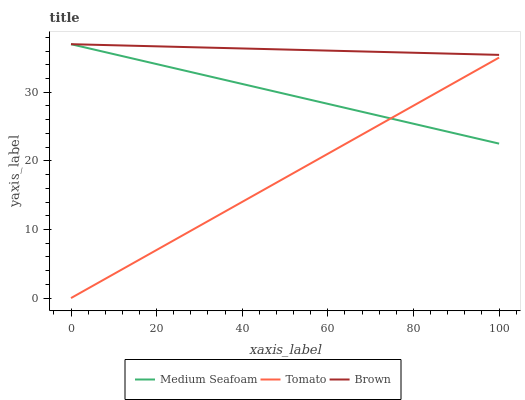Does Tomato have the minimum area under the curve?
Answer yes or no. Yes. Does Brown have the maximum area under the curve?
Answer yes or no. Yes. Does Medium Seafoam have the minimum area under the curve?
Answer yes or no. No. Does Medium Seafoam have the maximum area under the curve?
Answer yes or no. No. Is Tomato the smoothest?
Answer yes or no. Yes. Is Brown the roughest?
Answer yes or no. Yes. Is Medium Seafoam the smoothest?
Answer yes or no. No. Is Medium Seafoam the roughest?
Answer yes or no. No. Does Tomato have the lowest value?
Answer yes or no. Yes. Does Medium Seafoam have the lowest value?
Answer yes or no. No. Does Medium Seafoam have the highest value?
Answer yes or no. Yes. Is Tomato less than Brown?
Answer yes or no. Yes. Is Brown greater than Tomato?
Answer yes or no. Yes. Does Medium Seafoam intersect Brown?
Answer yes or no. Yes. Is Medium Seafoam less than Brown?
Answer yes or no. No. Is Medium Seafoam greater than Brown?
Answer yes or no. No. Does Tomato intersect Brown?
Answer yes or no. No. 